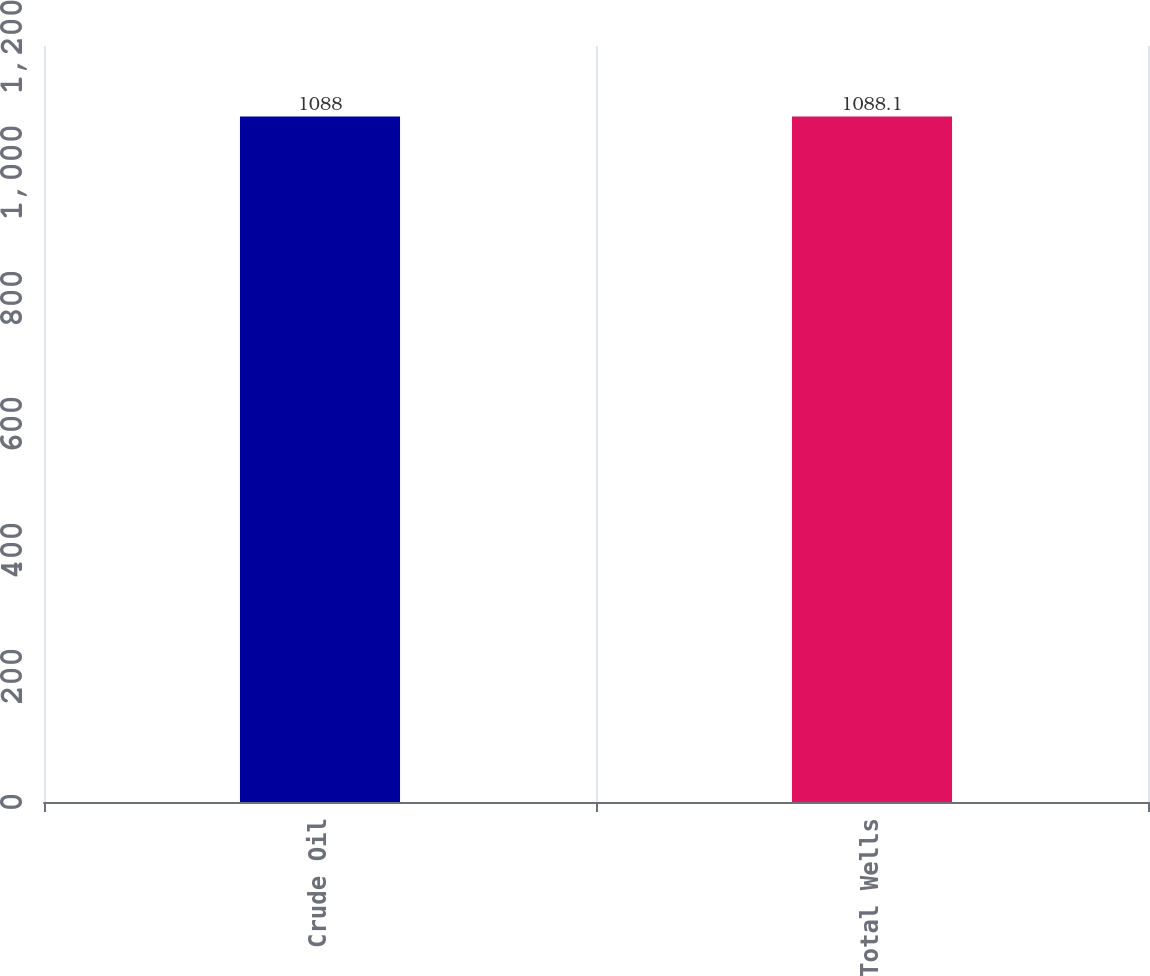<chart> <loc_0><loc_0><loc_500><loc_500><bar_chart><fcel>Crude Oil<fcel>Total Wells<nl><fcel>1088<fcel>1088.1<nl></chart> 